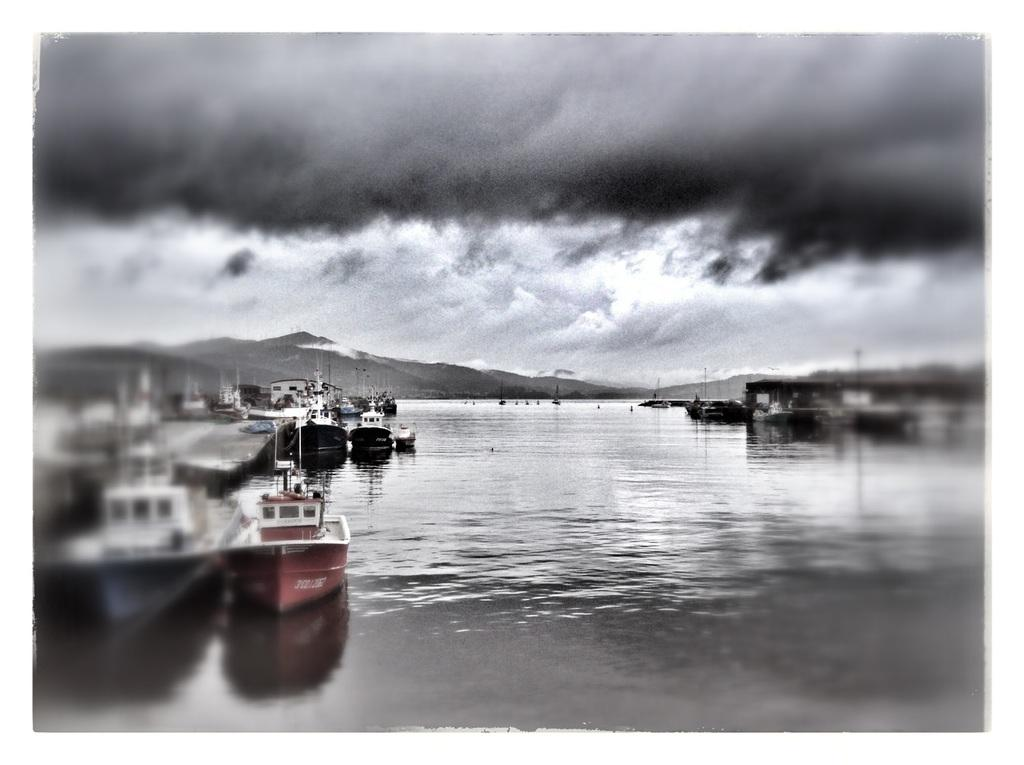What is the main subject of the image? The main subject of the image is a boat. What color is the boat? The boat is dark red in color. Where is the boat located in the image? The boat is on the left side of the image. What is the setting of the image? The boat is on water, and the sky is visible at the top of the image. What is the condition of the sky in the image? The sky is cloudy in the image. Who is the creator of the boat in the image? There is no information about the creator of the boat in the image. Are there any police officers visible in the image? There are no police officers present in the image. 